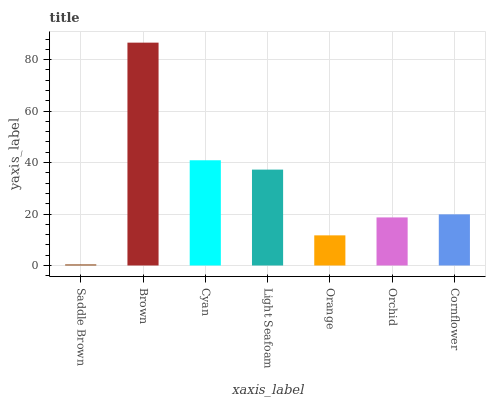Is Saddle Brown the minimum?
Answer yes or no. Yes. Is Brown the maximum?
Answer yes or no. Yes. Is Cyan the minimum?
Answer yes or no. No. Is Cyan the maximum?
Answer yes or no. No. Is Brown greater than Cyan?
Answer yes or no. Yes. Is Cyan less than Brown?
Answer yes or no. Yes. Is Cyan greater than Brown?
Answer yes or no. No. Is Brown less than Cyan?
Answer yes or no. No. Is Cornflower the high median?
Answer yes or no. Yes. Is Cornflower the low median?
Answer yes or no. Yes. Is Orchid the high median?
Answer yes or no. No. Is Cyan the low median?
Answer yes or no. No. 